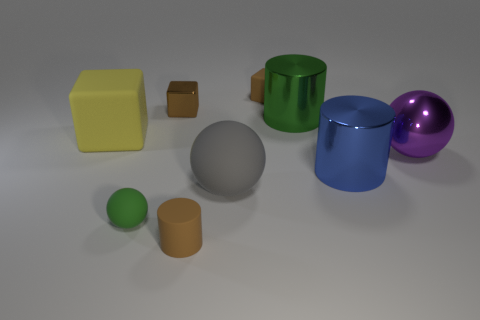The other rubber object that is the same shape as the gray matte thing is what color?
Provide a succinct answer. Green. Is the large green metallic object the same shape as the big blue object?
Your answer should be very brief. Yes. Are there any tiny metallic objects that have the same color as the tiny ball?
Your answer should be compact. No. Are there any red rubber objects?
Keep it short and to the point. No. Does the tiny cube that is to the left of the gray matte sphere have the same material as the big gray object?
Your answer should be compact. No. The cylinder that is the same color as the small rubber ball is what size?
Provide a succinct answer. Large. What number of yellow rubber blocks have the same size as the gray rubber thing?
Ensure brevity in your answer.  1. Is the number of small matte cubes that are on the right side of the green shiny cylinder the same as the number of yellow cylinders?
Provide a succinct answer. Yes. What number of things are both behind the large green metallic cylinder and on the right side of the tiny cylinder?
Offer a very short reply. 1. What is the size of the brown block that is made of the same material as the big green cylinder?
Your answer should be compact. Small. 